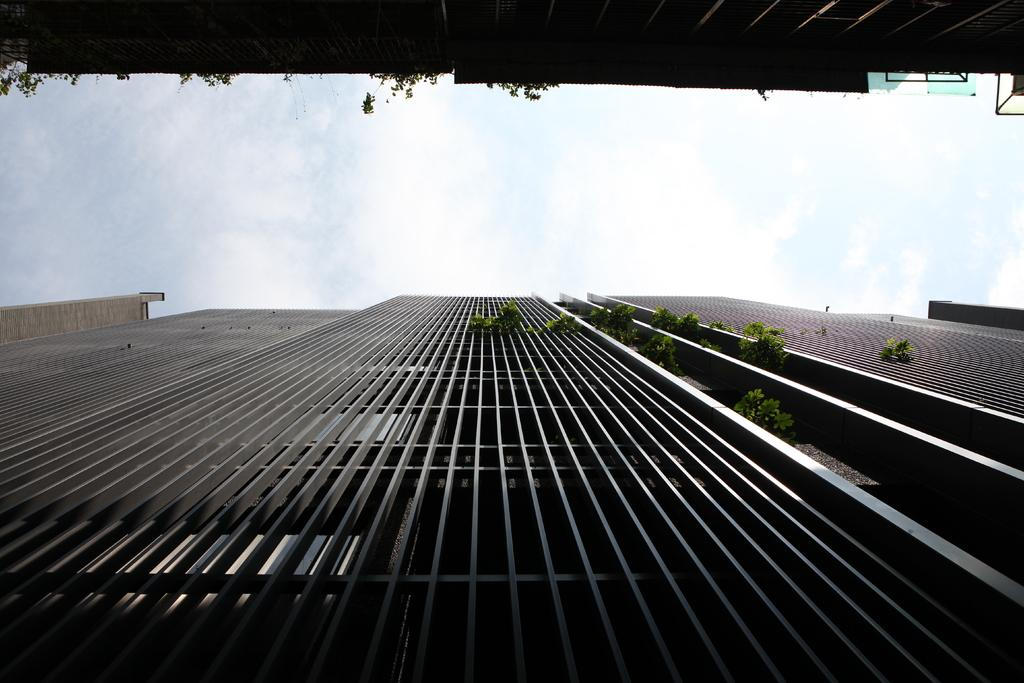What types of structures are present in the image? There are buildings in the image. What other elements can be seen in the image besides the buildings? There are plants in the image. What part of the natural environment is visible in the image? The sky is visible in the image. What type of paste can be seen on the buildings in the image? There is no paste present on the buildings in the image. Are there any flowers visible in the image? The provided facts do not mention flowers, so we cannot determine their presence from the image. 